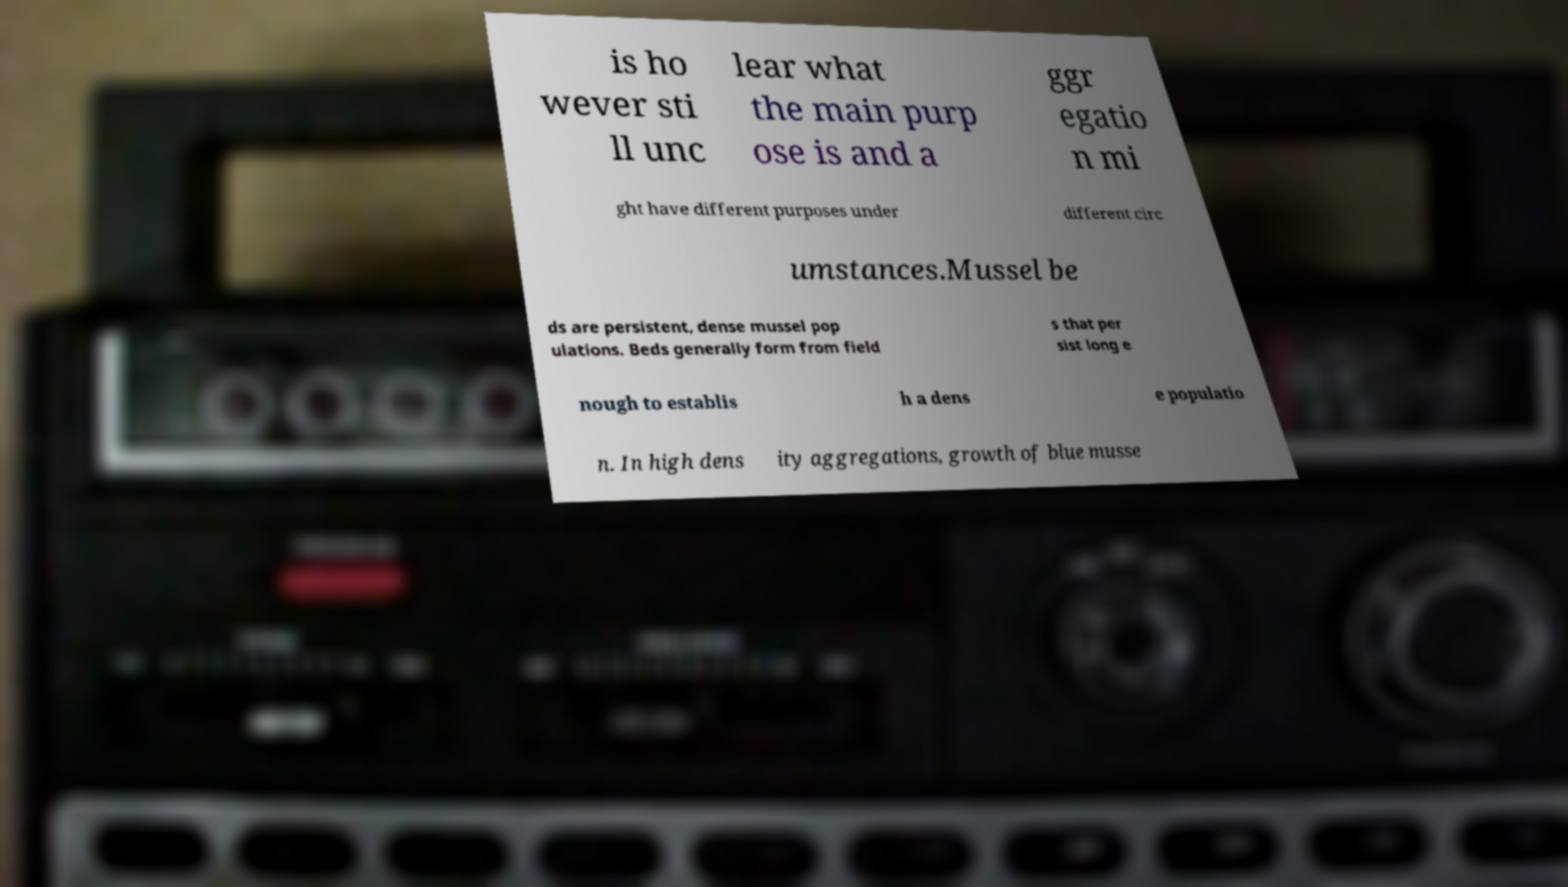Can you read and provide the text displayed in the image?This photo seems to have some interesting text. Can you extract and type it out for me? is ho wever sti ll unc lear what the main purp ose is and a ggr egatio n mi ght have different purposes under different circ umstances.Mussel be ds are persistent, dense mussel pop ulations. Beds generally form from field s that per sist long e nough to establis h a dens e populatio n. In high dens ity aggregations, growth of blue musse 